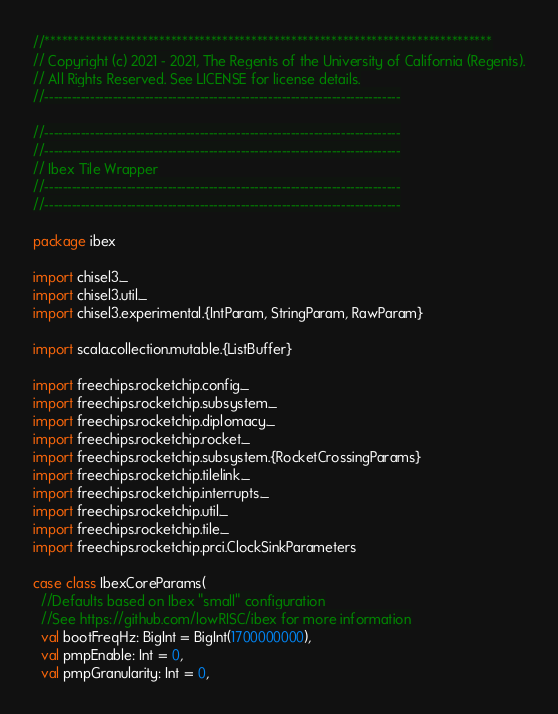Convert code to text. <code><loc_0><loc_0><loc_500><loc_500><_Scala_>//******************************************************************************
// Copyright (c) 2021 - 2021, The Regents of the University of California (Regents).
// All Rights Reserved. See LICENSE for license details.
//------------------------------------------------------------------------------

//------------------------------------------------------------------------------
//------------------------------------------------------------------------------
// Ibex Tile Wrapper
//------------------------------------------------------------------------------
//------------------------------------------------------------------------------

package ibex

import chisel3._
import chisel3.util._
import chisel3.experimental.{IntParam, StringParam, RawParam}

import scala.collection.mutable.{ListBuffer}

import freechips.rocketchip.config._
import freechips.rocketchip.subsystem._
import freechips.rocketchip.diplomacy._
import freechips.rocketchip.rocket._
import freechips.rocketchip.subsystem.{RocketCrossingParams}
import freechips.rocketchip.tilelink._
import freechips.rocketchip.interrupts._
import freechips.rocketchip.util._
import freechips.rocketchip.tile._
import freechips.rocketchip.prci.ClockSinkParameters 

case class IbexCoreParams(
  //Defaults based on Ibex "small" configuration
  //See https://github.com/lowRISC/ibex for more information
  val bootFreqHz: BigInt = BigInt(1700000000),
  val pmpEnable: Int = 0,
  val pmpGranularity: Int = 0,</code> 